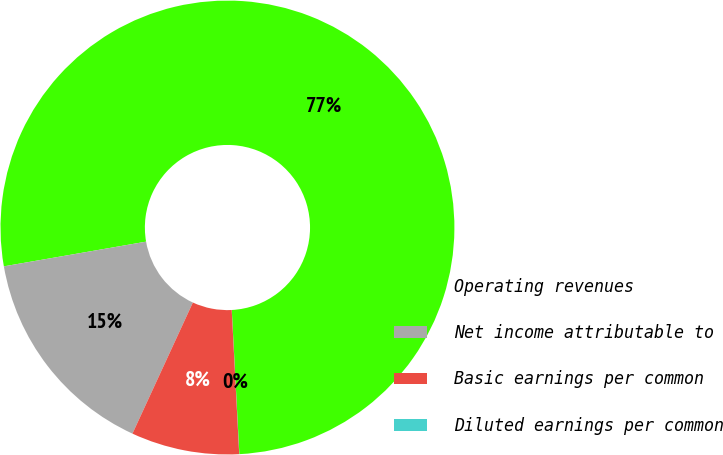<chart> <loc_0><loc_0><loc_500><loc_500><pie_chart><fcel>Operating revenues<fcel>Net income attributable to<fcel>Basic earnings per common<fcel>Diluted earnings per common<nl><fcel>76.9%<fcel>15.39%<fcel>7.7%<fcel>0.01%<nl></chart> 